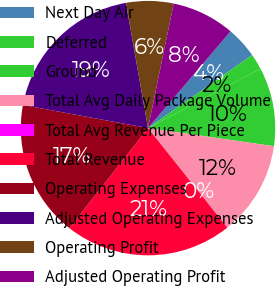Convert chart to OTSL. <chart><loc_0><loc_0><loc_500><loc_500><pie_chart><fcel>Next Day Air<fcel>Deferred<fcel>Ground<fcel>Total Avg Daily Package Volume<fcel>Total Avg Revenue Per Piece<fcel>Total Revenue<fcel>Operating Expenses<fcel>Adjusted Operating Expenses<fcel>Operating Profit<fcel>Adjusted Operating Profit<nl><fcel>4.01%<fcel>2.01%<fcel>10.01%<fcel>12.01%<fcel>0.01%<fcel>21.31%<fcel>17.31%<fcel>19.31%<fcel>6.01%<fcel>8.01%<nl></chart> 